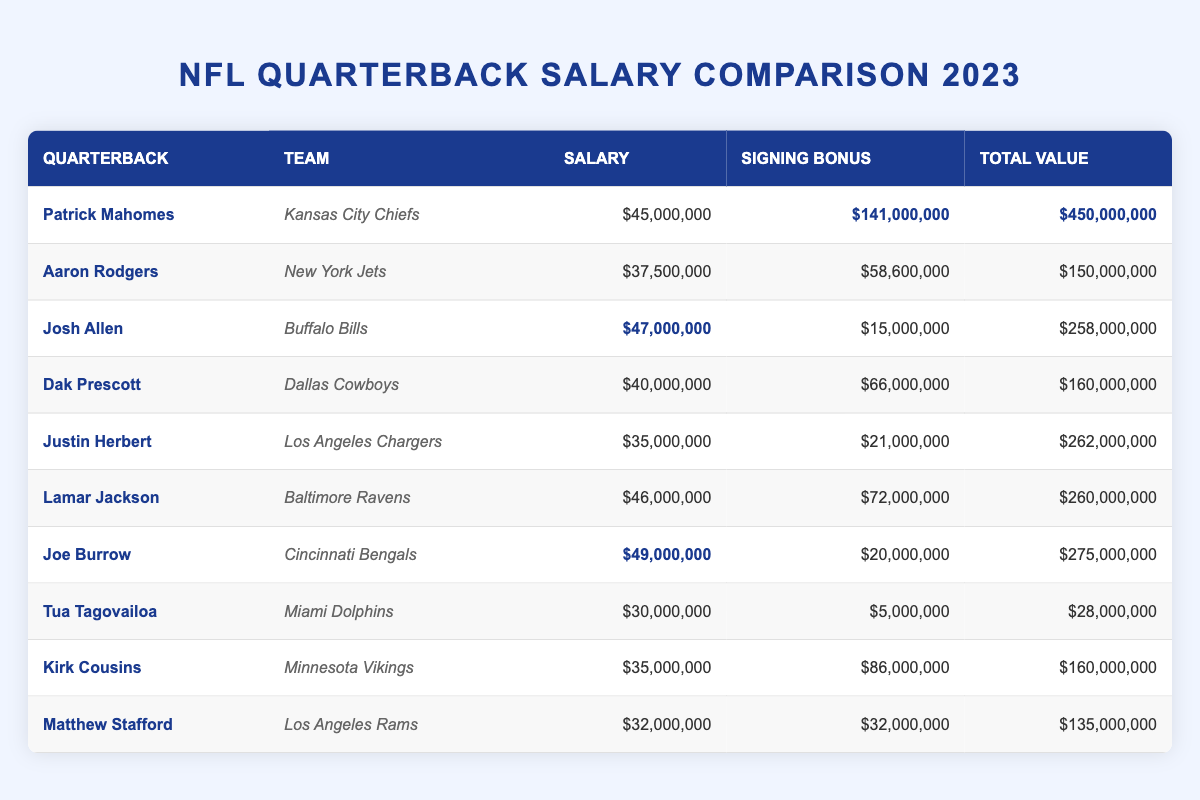What is the highest salary among the quarterbacks? The table shows that Patrick Mahomes has the highest salary of $45,000,000.
Answer: $45,000,000 Which quarterback has the largest signing bonus? By scanning the table, we see that Patrick Mahomes has a signing bonus of $141,000,000, which is the largest among the quarterbacks.
Answer: $141,000,000 What is the total value of Joe Burrow’s contract? Referring to the table, Joe Burrow's total value is listed as $275,000,000.
Answer: $275,000,000 Which team does Dak Prescott play for? The table indicates that Dak Prescott plays for the Dallas Cowboys.
Answer: Dallas Cowboys How much higher is Lamar Jackson's salary compared to Tua Tagovailoa's? Lamar Jackson's salary is $46,000,000 and Tua Tagovailoa's is $30,000,000. The difference is $46,000,000 - $30,000,000 = $16,000,000.
Answer: $16,000,000 What is the average signing bonus of all quarterbacks listed? To find the average, we sum the signing bonuses: $141,000,000 + $58,600,000 + $15,000,000 + $66,000,000 + $21,000,000 + $72,000,000 + $20,000,000 + $5,000,000 + $86,000,000 + $32,000,000 = $405,600,000. There are 10 quarterbacks, so the average is $405,600,000 / 10 = $40,560,000.
Answer: $40,560,000 Is Justin Herbert's total contract value less than $300,000,000? The table shows that Justin Herbert's total contract value is $262,000,000, which is indeed less than $300,000,000.
Answer: Yes Who has the smallest total contract value in this list? Looking through the total values, Tua Tagovailoa has the smallest total contract value of $28,000,000.
Answer: $28,000,000 If we add the salaries of Patrick Mahomes and Josh Allen, what do we get? The salary of Patrick Mahomes is $45,000,000 and Josh Allen's is $47,000,000. Adding these gives us $45,000,000 + $47,000,000 = $92,000,000.
Answer: $92,000,000 How much more is Joe Burrow's signing bonus compared to Aaron Rodgers’? Joe Burrow's signing bonus is $20,000,000 and Aaron Rodgers’ is $58,600,000. Calculating the difference: $20,000,000 - $58,600,000 = -$38,600,000, which shows Joe Burrow has $38,600,000 less.
Answer: $38,600,000 less What percentage of total value does Patrick Mahomes’ signing bonus represent? Patrick Mahomes’ signing bonus is $141,000,000 and his total value is $450,000,000. The percentage is ($141,000,000 / $450,000,000) * 100 = 31.33%.
Answer: 31.33% 